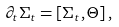<formula> <loc_0><loc_0><loc_500><loc_500>\partial _ { t } \Sigma _ { t } = [ \Sigma _ { t } , \Theta ] \, ,</formula> 